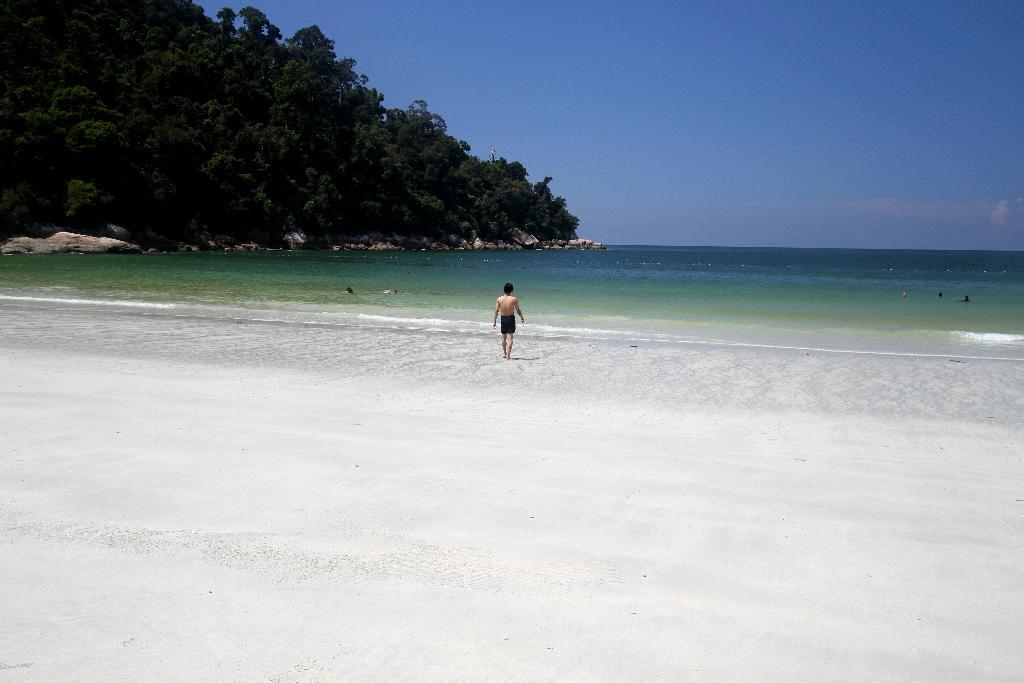What is the person in the image doing? The person is walking in the image. Where is the person walking? The person is on a beach. What can be seen on the left side of the image? There are trees on the left side of the image. What is visible in the background of the image? The sky is visible in the background of the image. What type of brush is being used to paint the trees in the image? There is no brush or painting activity present in the image; it features a person walking on a beach with trees on the left side and the sky visible in the background. 